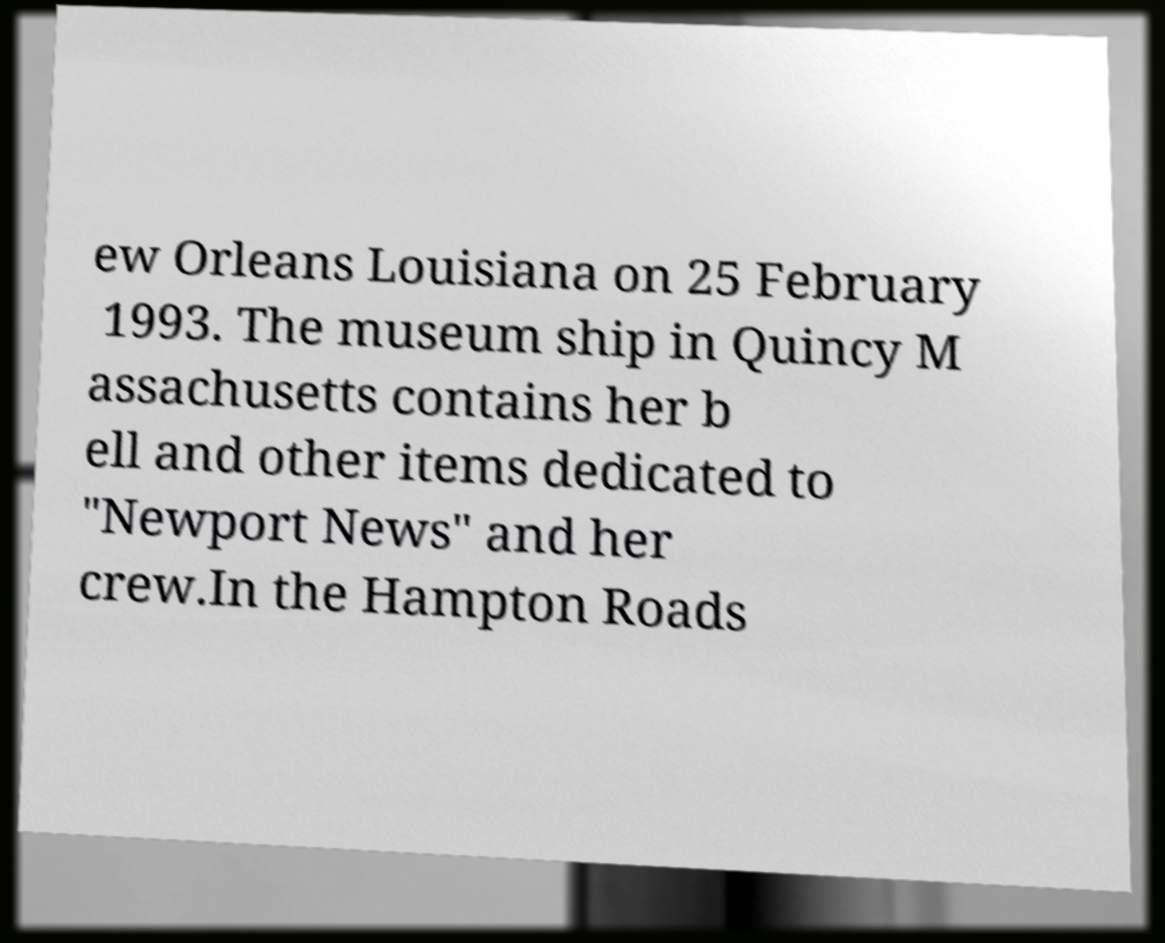Please read and relay the text visible in this image. What does it say? ew Orleans Louisiana on 25 February 1993. The museum ship in Quincy M assachusetts contains her b ell and other items dedicated to "Newport News" and her crew.In the Hampton Roads 